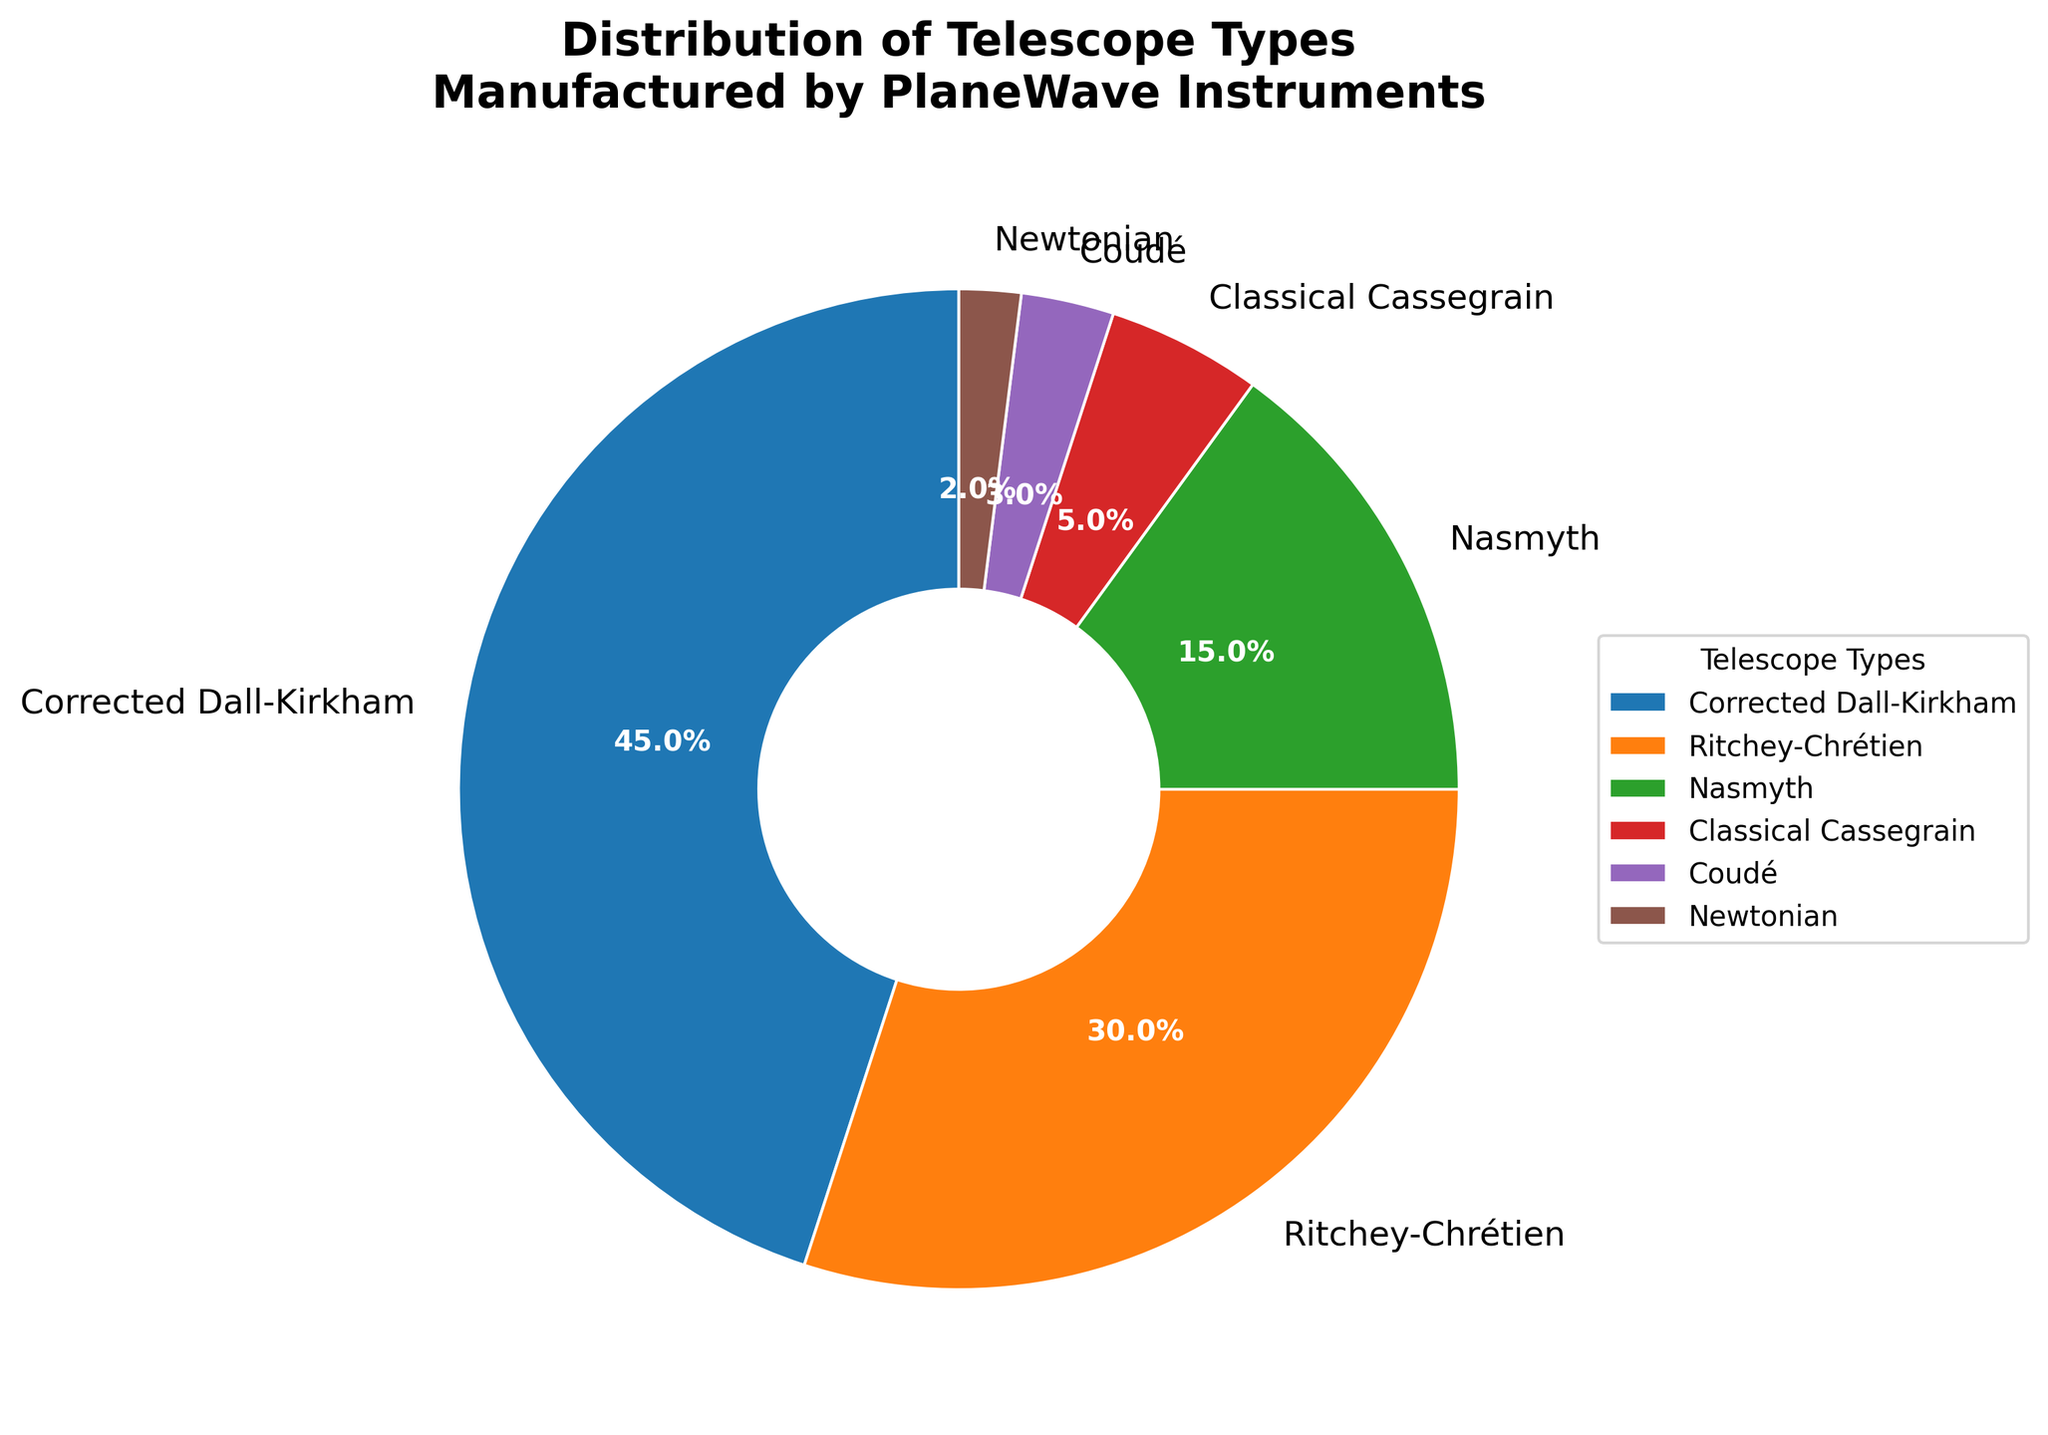What is the most common telescope type manufactured by PlaneWave Instruments? The figure shows that the Corrected Dall-Kirkham type covers the largest portion of the pie chart, which means it has the highest percentage.
Answer: Corrected Dall-Kirkham What is the total percentage of Ritchey-Chrétien and Nasmyth telescopes combined? The figure shows that Ritchey-Chrétien telescopes are 30% and Nasmyth telescopes are 15%. Adding these two percentages, 30% + 15%, gives us the total percentage.
Answer: 45% Which telescope type accounts for the smallest percentage in the distribution? By observing the pie chart, the Newtonian telescope type has the smallest slice, indicating that it has the lowest percentage.
Answer: Newtonian How much more percentage does the Corrected Dall-Kirkham type have compared to Classical Cassegrain? The Corrected Dall-Kirkham type is 45%, while the Classical Cassegrain type is 5%. Subtracting these two, 45% - 5%, shows the difference.
Answer: 40% Which telescope types have a combined percentage equal to the percentage of Ritchey-Chrétien telescopes? The figure shows that Ritchey-Chrétien telescopes account for 30%. Looking at the other telescope types: Nasmyth (15%), Classical Cassegrain (5%), Coudé (3%), and Newtonian (2%) have a combined total of 15% + 5% + 3% + 2% = 25%, which doesn't match. The Corrected Dall-Kirkham (45%) minus 15% (Nasmyth) equals the Ritchey-Chrétien percentage of 30%.
Answer: None Which telescope types together make up more than half of the total distribution? The Corrected Dall-Kirkham (45%) and Ritchey-Chrétien (30%) combined give a total of 75%, which is more than half of the 100% total.
Answer: Corrected Dall-Kirkham and Ritchey-Chrétien What is the difference in percentages between the Nasmyth and Coudé telescope types? The pie chart shows Nasmyth telescopes at 15% and Coudé at 3%. The difference is calculated as 15% - 3%.
Answer: 12% Which color represents the Classical Cassegrain telescope type? Visually, you can identify that the Classical Cassegrain telescope type is represented by a specific portion of the pie chart colored in one of the shades available. In this case, it is colored purple.
Answer: Purple 